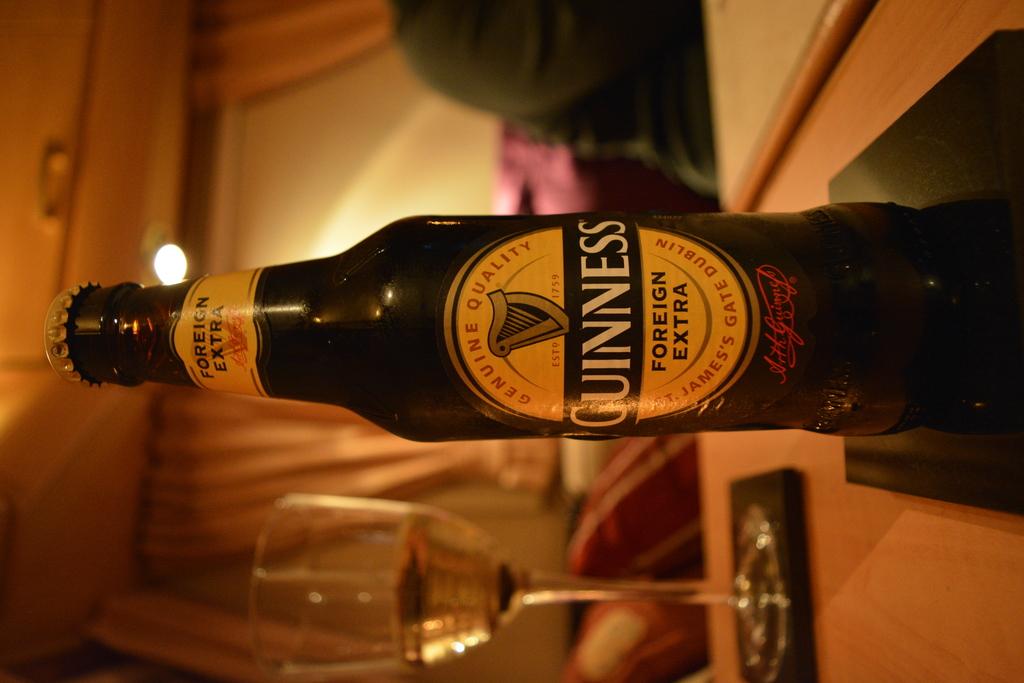What brand of beer is this?
Your answer should be very brief. Guinness. 